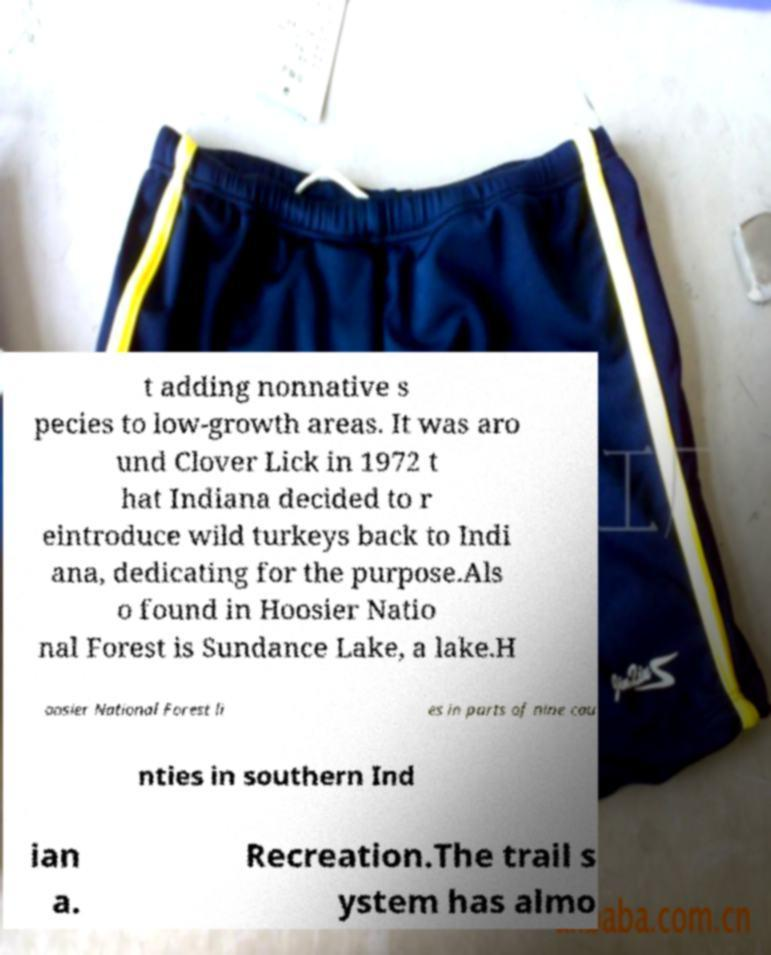Could you extract and type out the text from this image? t adding nonnative s pecies to low-growth areas. It was aro und Clover Lick in 1972 t hat Indiana decided to r eintroduce wild turkeys back to Indi ana, dedicating for the purpose.Als o found in Hoosier Natio nal Forest is Sundance Lake, a lake.H oosier National Forest li es in parts of nine cou nties in southern Ind ian a. Recreation.The trail s ystem has almo 